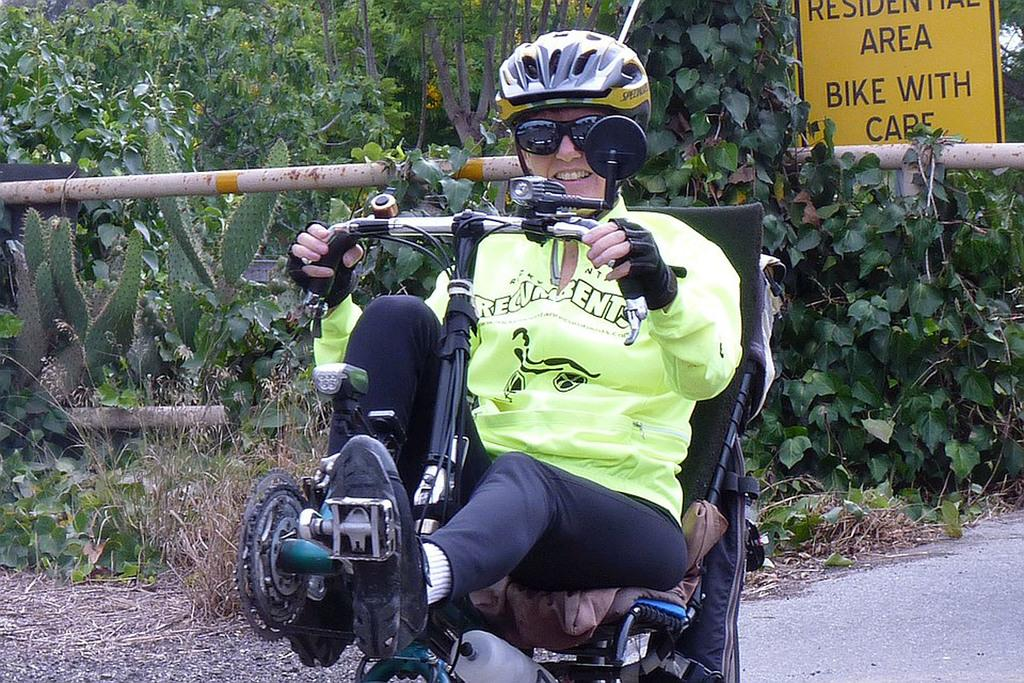What is the person in the image doing? There is a person riding a vehicle in the image. What can be seen in the background of the image? There are many plants and trees in the background of the image. Can you describe any specific signs or warnings in the image? Yes, there is a caution board visible between the plants in the image. What type of flower is in the jar on the stage in the image? There is no stage, flower, or jar present in the image. 